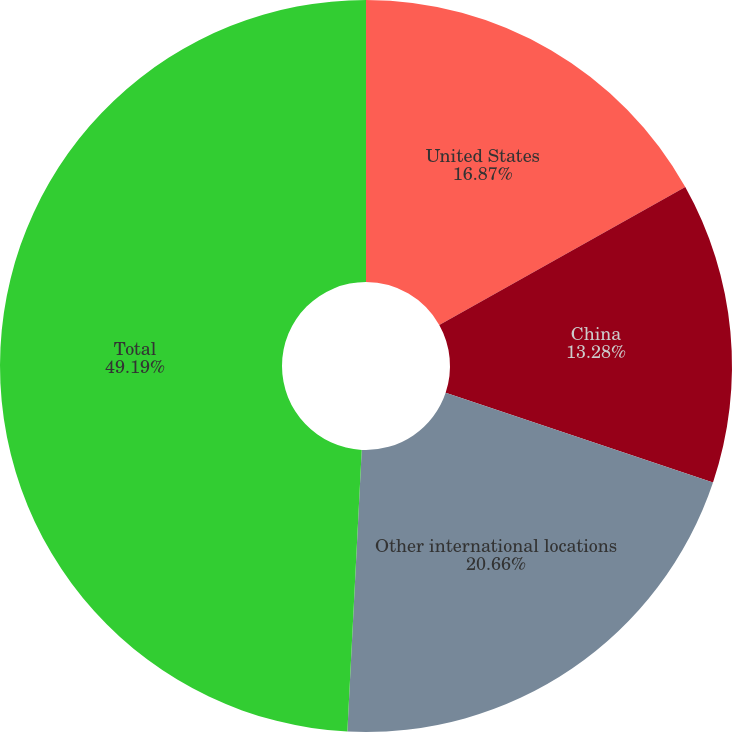<chart> <loc_0><loc_0><loc_500><loc_500><pie_chart><fcel>United States<fcel>China<fcel>Other international locations<fcel>Total<nl><fcel>16.87%<fcel>13.28%<fcel>20.66%<fcel>49.19%<nl></chart> 